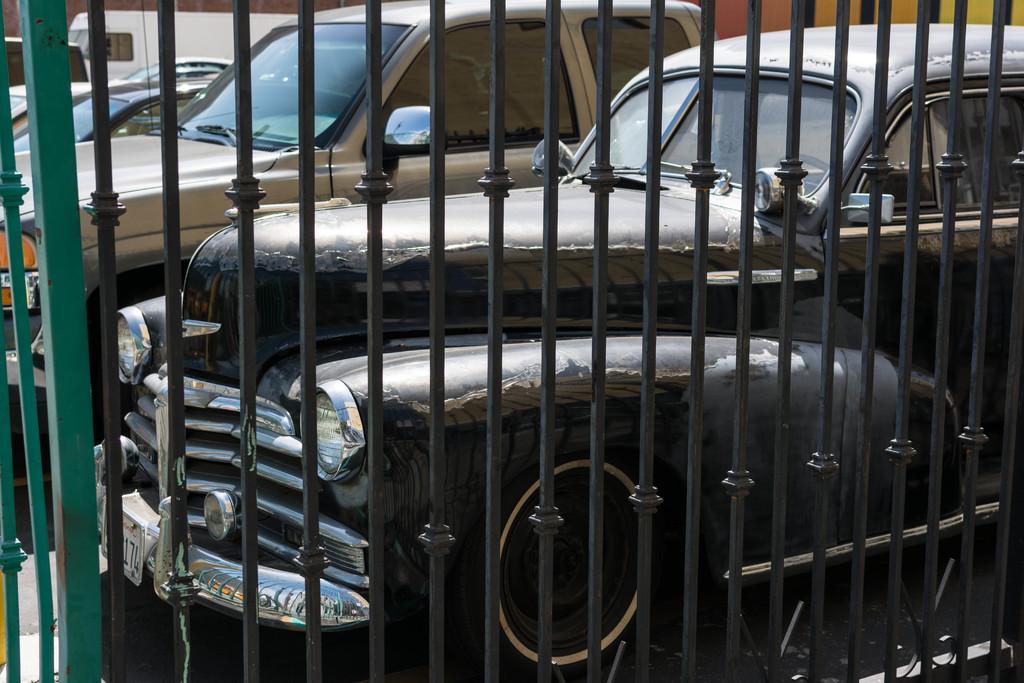In one or two sentences, can you explain what this image depicts? In this picture I can see few cars and a vehicle parked and I can see metal fence. 